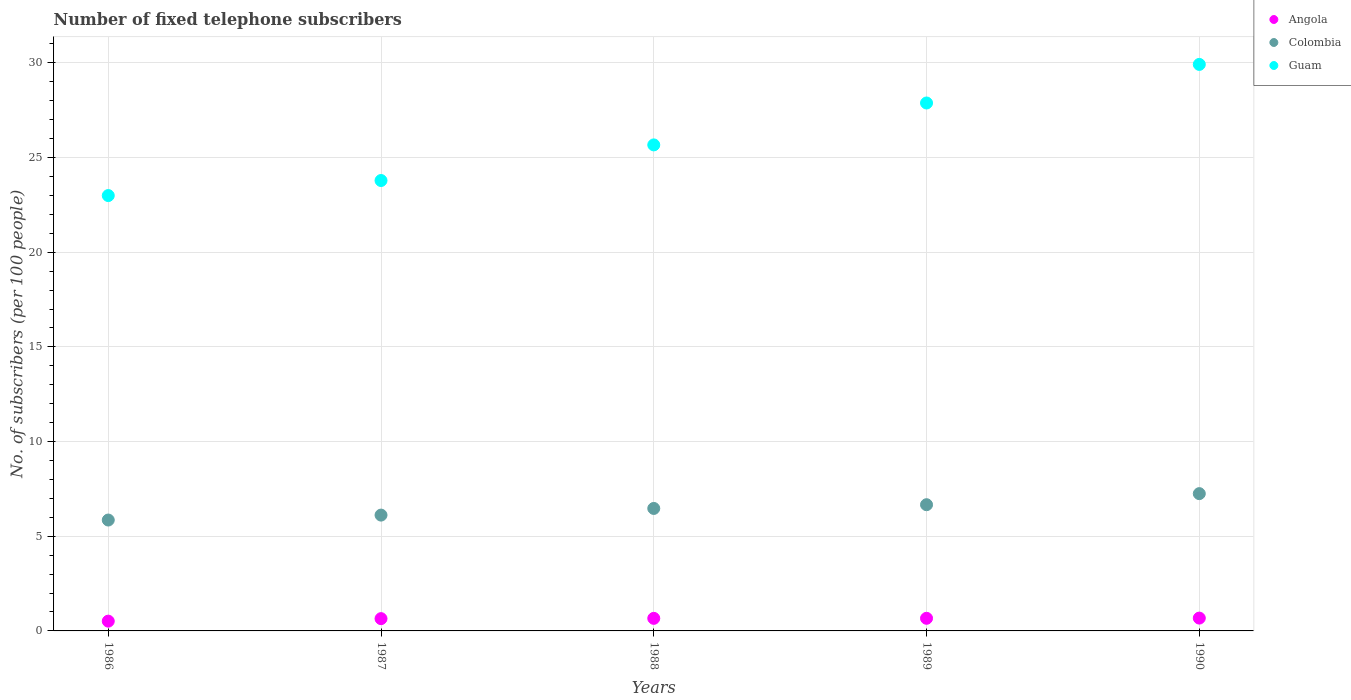How many different coloured dotlines are there?
Offer a very short reply. 3. What is the number of fixed telephone subscribers in Colombia in 1989?
Your response must be concise. 6.66. Across all years, what is the maximum number of fixed telephone subscribers in Colombia?
Keep it short and to the point. 7.25. Across all years, what is the minimum number of fixed telephone subscribers in Colombia?
Make the answer very short. 5.86. What is the total number of fixed telephone subscribers in Colombia in the graph?
Your response must be concise. 32.36. What is the difference between the number of fixed telephone subscribers in Colombia in 1986 and that in 1987?
Your answer should be very brief. -0.26. What is the difference between the number of fixed telephone subscribers in Guam in 1989 and the number of fixed telephone subscribers in Colombia in 1986?
Offer a very short reply. 22.02. What is the average number of fixed telephone subscribers in Guam per year?
Offer a very short reply. 26.05. In the year 1988, what is the difference between the number of fixed telephone subscribers in Guam and number of fixed telephone subscribers in Colombia?
Your response must be concise. 19.2. What is the ratio of the number of fixed telephone subscribers in Angola in 1987 to that in 1989?
Make the answer very short. 0.97. Is the difference between the number of fixed telephone subscribers in Guam in 1986 and 1988 greater than the difference between the number of fixed telephone subscribers in Colombia in 1986 and 1988?
Give a very brief answer. No. What is the difference between the highest and the second highest number of fixed telephone subscribers in Colombia?
Your answer should be compact. 0.59. What is the difference between the highest and the lowest number of fixed telephone subscribers in Angola?
Your answer should be very brief. 0.16. Is the sum of the number of fixed telephone subscribers in Colombia in 1986 and 1989 greater than the maximum number of fixed telephone subscribers in Guam across all years?
Your answer should be very brief. No. Does the number of fixed telephone subscribers in Angola monotonically increase over the years?
Your answer should be compact. Yes. How many dotlines are there?
Provide a short and direct response. 3. Does the graph contain any zero values?
Provide a succinct answer. No. Does the graph contain grids?
Provide a short and direct response. Yes. How many legend labels are there?
Ensure brevity in your answer.  3. What is the title of the graph?
Offer a terse response. Number of fixed telephone subscribers. What is the label or title of the Y-axis?
Provide a succinct answer. No. of subscribers (per 100 people). What is the No. of subscribers (per 100 people) in Angola in 1986?
Offer a terse response. 0.52. What is the No. of subscribers (per 100 people) of Colombia in 1986?
Ensure brevity in your answer.  5.86. What is the No. of subscribers (per 100 people) in Guam in 1986?
Make the answer very short. 22.99. What is the No. of subscribers (per 100 people) of Angola in 1987?
Offer a terse response. 0.65. What is the No. of subscribers (per 100 people) of Colombia in 1987?
Provide a short and direct response. 6.12. What is the No. of subscribers (per 100 people) in Guam in 1987?
Your answer should be compact. 23.79. What is the No. of subscribers (per 100 people) in Angola in 1988?
Give a very brief answer. 0.66. What is the No. of subscribers (per 100 people) in Colombia in 1988?
Ensure brevity in your answer.  6.47. What is the No. of subscribers (per 100 people) of Guam in 1988?
Provide a short and direct response. 25.67. What is the No. of subscribers (per 100 people) of Angola in 1989?
Ensure brevity in your answer.  0.67. What is the No. of subscribers (per 100 people) of Colombia in 1989?
Your answer should be compact. 6.66. What is the No. of subscribers (per 100 people) of Guam in 1989?
Your response must be concise. 27.88. What is the No. of subscribers (per 100 people) in Angola in 1990?
Make the answer very short. 0.68. What is the No. of subscribers (per 100 people) of Colombia in 1990?
Provide a short and direct response. 7.25. What is the No. of subscribers (per 100 people) of Guam in 1990?
Your answer should be very brief. 29.92. Across all years, what is the maximum No. of subscribers (per 100 people) of Angola?
Make the answer very short. 0.68. Across all years, what is the maximum No. of subscribers (per 100 people) of Colombia?
Your response must be concise. 7.25. Across all years, what is the maximum No. of subscribers (per 100 people) of Guam?
Provide a succinct answer. 29.92. Across all years, what is the minimum No. of subscribers (per 100 people) in Angola?
Your response must be concise. 0.52. Across all years, what is the minimum No. of subscribers (per 100 people) of Colombia?
Offer a terse response. 5.86. Across all years, what is the minimum No. of subscribers (per 100 people) in Guam?
Ensure brevity in your answer.  22.99. What is the total No. of subscribers (per 100 people) of Angola in the graph?
Ensure brevity in your answer.  3.17. What is the total No. of subscribers (per 100 people) of Colombia in the graph?
Your response must be concise. 32.36. What is the total No. of subscribers (per 100 people) of Guam in the graph?
Provide a short and direct response. 130.24. What is the difference between the No. of subscribers (per 100 people) in Angola in 1986 and that in 1987?
Ensure brevity in your answer.  -0.13. What is the difference between the No. of subscribers (per 100 people) in Colombia in 1986 and that in 1987?
Keep it short and to the point. -0.26. What is the difference between the No. of subscribers (per 100 people) in Guam in 1986 and that in 1987?
Offer a terse response. -0.79. What is the difference between the No. of subscribers (per 100 people) in Angola in 1986 and that in 1988?
Keep it short and to the point. -0.15. What is the difference between the No. of subscribers (per 100 people) of Colombia in 1986 and that in 1988?
Your answer should be compact. -0.61. What is the difference between the No. of subscribers (per 100 people) of Guam in 1986 and that in 1988?
Ensure brevity in your answer.  -2.68. What is the difference between the No. of subscribers (per 100 people) of Angola in 1986 and that in 1989?
Offer a terse response. -0.15. What is the difference between the No. of subscribers (per 100 people) of Colombia in 1986 and that in 1989?
Your answer should be very brief. -0.81. What is the difference between the No. of subscribers (per 100 people) in Guam in 1986 and that in 1989?
Offer a terse response. -4.89. What is the difference between the No. of subscribers (per 100 people) in Angola in 1986 and that in 1990?
Keep it short and to the point. -0.16. What is the difference between the No. of subscribers (per 100 people) in Colombia in 1986 and that in 1990?
Your answer should be very brief. -1.39. What is the difference between the No. of subscribers (per 100 people) in Guam in 1986 and that in 1990?
Offer a terse response. -6.93. What is the difference between the No. of subscribers (per 100 people) of Angola in 1987 and that in 1988?
Your answer should be very brief. -0.01. What is the difference between the No. of subscribers (per 100 people) of Colombia in 1987 and that in 1988?
Your answer should be very brief. -0.35. What is the difference between the No. of subscribers (per 100 people) in Guam in 1987 and that in 1988?
Offer a terse response. -1.88. What is the difference between the No. of subscribers (per 100 people) of Angola in 1987 and that in 1989?
Keep it short and to the point. -0.02. What is the difference between the No. of subscribers (per 100 people) in Colombia in 1987 and that in 1989?
Give a very brief answer. -0.55. What is the difference between the No. of subscribers (per 100 people) of Guam in 1987 and that in 1989?
Offer a terse response. -4.09. What is the difference between the No. of subscribers (per 100 people) in Angola in 1987 and that in 1990?
Your response must be concise. -0.03. What is the difference between the No. of subscribers (per 100 people) of Colombia in 1987 and that in 1990?
Offer a very short reply. -1.13. What is the difference between the No. of subscribers (per 100 people) in Guam in 1987 and that in 1990?
Provide a short and direct response. -6.13. What is the difference between the No. of subscribers (per 100 people) of Angola in 1988 and that in 1989?
Ensure brevity in your answer.  -0. What is the difference between the No. of subscribers (per 100 people) of Colombia in 1988 and that in 1989?
Provide a succinct answer. -0.2. What is the difference between the No. of subscribers (per 100 people) of Guam in 1988 and that in 1989?
Offer a very short reply. -2.21. What is the difference between the No. of subscribers (per 100 people) of Angola in 1988 and that in 1990?
Ensure brevity in your answer.  -0.01. What is the difference between the No. of subscribers (per 100 people) in Colombia in 1988 and that in 1990?
Offer a terse response. -0.78. What is the difference between the No. of subscribers (per 100 people) in Guam in 1988 and that in 1990?
Provide a short and direct response. -4.25. What is the difference between the No. of subscribers (per 100 people) in Angola in 1989 and that in 1990?
Give a very brief answer. -0.01. What is the difference between the No. of subscribers (per 100 people) in Colombia in 1989 and that in 1990?
Make the answer very short. -0.59. What is the difference between the No. of subscribers (per 100 people) in Guam in 1989 and that in 1990?
Your answer should be very brief. -2.04. What is the difference between the No. of subscribers (per 100 people) of Angola in 1986 and the No. of subscribers (per 100 people) of Colombia in 1987?
Your answer should be very brief. -5.6. What is the difference between the No. of subscribers (per 100 people) in Angola in 1986 and the No. of subscribers (per 100 people) in Guam in 1987?
Your answer should be compact. -23.27. What is the difference between the No. of subscribers (per 100 people) of Colombia in 1986 and the No. of subscribers (per 100 people) of Guam in 1987?
Your answer should be compact. -17.93. What is the difference between the No. of subscribers (per 100 people) in Angola in 1986 and the No. of subscribers (per 100 people) in Colombia in 1988?
Ensure brevity in your answer.  -5.95. What is the difference between the No. of subscribers (per 100 people) of Angola in 1986 and the No. of subscribers (per 100 people) of Guam in 1988?
Provide a succinct answer. -25.15. What is the difference between the No. of subscribers (per 100 people) in Colombia in 1986 and the No. of subscribers (per 100 people) in Guam in 1988?
Keep it short and to the point. -19.81. What is the difference between the No. of subscribers (per 100 people) in Angola in 1986 and the No. of subscribers (per 100 people) in Colombia in 1989?
Give a very brief answer. -6.15. What is the difference between the No. of subscribers (per 100 people) of Angola in 1986 and the No. of subscribers (per 100 people) of Guam in 1989?
Give a very brief answer. -27.36. What is the difference between the No. of subscribers (per 100 people) of Colombia in 1986 and the No. of subscribers (per 100 people) of Guam in 1989?
Provide a succinct answer. -22.02. What is the difference between the No. of subscribers (per 100 people) in Angola in 1986 and the No. of subscribers (per 100 people) in Colombia in 1990?
Keep it short and to the point. -6.73. What is the difference between the No. of subscribers (per 100 people) of Angola in 1986 and the No. of subscribers (per 100 people) of Guam in 1990?
Keep it short and to the point. -29.4. What is the difference between the No. of subscribers (per 100 people) of Colombia in 1986 and the No. of subscribers (per 100 people) of Guam in 1990?
Give a very brief answer. -24.06. What is the difference between the No. of subscribers (per 100 people) of Angola in 1987 and the No. of subscribers (per 100 people) of Colombia in 1988?
Offer a terse response. -5.82. What is the difference between the No. of subscribers (per 100 people) of Angola in 1987 and the No. of subscribers (per 100 people) of Guam in 1988?
Offer a very short reply. -25.02. What is the difference between the No. of subscribers (per 100 people) in Colombia in 1987 and the No. of subscribers (per 100 people) in Guam in 1988?
Your response must be concise. -19.55. What is the difference between the No. of subscribers (per 100 people) in Angola in 1987 and the No. of subscribers (per 100 people) in Colombia in 1989?
Provide a short and direct response. -6.02. What is the difference between the No. of subscribers (per 100 people) of Angola in 1987 and the No. of subscribers (per 100 people) of Guam in 1989?
Provide a short and direct response. -27.23. What is the difference between the No. of subscribers (per 100 people) in Colombia in 1987 and the No. of subscribers (per 100 people) in Guam in 1989?
Provide a succinct answer. -21.76. What is the difference between the No. of subscribers (per 100 people) of Angola in 1987 and the No. of subscribers (per 100 people) of Colombia in 1990?
Ensure brevity in your answer.  -6.6. What is the difference between the No. of subscribers (per 100 people) in Angola in 1987 and the No. of subscribers (per 100 people) in Guam in 1990?
Make the answer very short. -29.27. What is the difference between the No. of subscribers (per 100 people) of Colombia in 1987 and the No. of subscribers (per 100 people) of Guam in 1990?
Make the answer very short. -23.8. What is the difference between the No. of subscribers (per 100 people) of Angola in 1988 and the No. of subscribers (per 100 people) of Colombia in 1989?
Offer a terse response. -6. What is the difference between the No. of subscribers (per 100 people) in Angola in 1988 and the No. of subscribers (per 100 people) in Guam in 1989?
Your response must be concise. -27.22. What is the difference between the No. of subscribers (per 100 people) in Colombia in 1988 and the No. of subscribers (per 100 people) in Guam in 1989?
Your answer should be very brief. -21.41. What is the difference between the No. of subscribers (per 100 people) of Angola in 1988 and the No. of subscribers (per 100 people) of Colombia in 1990?
Give a very brief answer. -6.59. What is the difference between the No. of subscribers (per 100 people) in Angola in 1988 and the No. of subscribers (per 100 people) in Guam in 1990?
Keep it short and to the point. -29.25. What is the difference between the No. of subscribers (per 100 people) of Colombia in 1988 and the No. of subscribers (per 100 people) of Guam in 1990?
Provide a short and direct response. -23.45. What is the difference between the No. of subscribers (per 100 people) of Angola in 1989 and the No. of subscribers (per 100 people) of Colombia in 1990?
Give a very brief answer. -6.58. What is the difference between the No. of subscribers (per 100 people) in Angola in 1989 and the No. of subscribers (per 100 people) in Guam in 1990?
Offer a terse response. -29.25. What is the difference between the No. of subscribers (per 100 people) of Colombia in 1989 and the No. of subscribers (per 100 people) of Guam in 1990?
Your response must be concise. -23.25. What is the average No. of subscribers (per 100 people) in Angola per year?
Provide a short and direct response. 0.63. What is the average No. of subscribers (per 100 people) of Colombia per year?
Your answer should be compact. 6.47. What is the average No. of subscribers (per 100 people) of Guam per year?
Offer a terse response. 26.05. In the year 1986, what is the difference between the No. of subscribers (per 100 people) of Angola and No. of subscribers (per 100 people) of Colombia?
Your answer should be very brief. -5.34. In the year 1986, what is the difference between the No. of subscribers (per 100 people) of Angola and No. of subscribers (per 100 people) of Guam?
Offer a terse response. -22.47. In the year 1986, what is the difference between the No. of subscribers (per 100 people) in Colombia and No. of subscribers (per 100 people) in Guam?
Offer a terse response. -17.13. In the year 1987, what is the difference between the No. of subscribers (per 100 people) of Angola and No. of subscribers (per 100 people) of Colombia?
Offer a terse response. -5.47. In the year 1987, what is the difference between the No. of subscribers (per 100 people) of Angola and No. of subscribers (per 100 people) of Guam?
Ensure brevity in your answer.  -23.14. In the year 1987, what is the difference between the No. of subscribers (per 100 people) of Colombia and No. of subscribers (per 100 people) of Guam?
Offer a terse response. -17.67. In the year 1988, what is the difference between the No. of subscribers (per 100 people) in Angola and No. of subscribers (per 100 people) in Colombia?
Your answer should be compact. -5.8. In the year 1988, what is the difference between the No. of subscribers (per 100 people) of Angola and No. of subscribers (per 100 people) of Guam?
Give a very brief answer. -25. In the year 1988, what is the difference between the No. of subscribers (per 100 people) in Colombia and No. of subscribers (per 100 people) in Guam?
Offer a very short reply. -19.2. In the year 1989, what is the difference between the No. of subscribers (per 100 people) in Angola and No. of subscribers (per 100 people) in Colombia?
Provide a short and direct response. -6. In the year 1989, what is the difference between the No. of subscribers (per 100 people) of Angola and No. of subscribers (per 100 people) of Guam?
Ensure brevity in your answer.  -27.21. In the year 1989, what is the difference between the No. of subscribers (per 100 people) of Colombia and No. of subscribers (per 100 people) of Guam?
Your answer should be very brief. -21.21. In the year 1990, what is the difference between the No. of subscribers (per 100 people) of Angola and No. of subscribers (per 100 people) of Colombia?
Give a very brief answer. -6.57. In the year 1990, what is the difference between the No. of subscribers (per 100 people) in Angola and No. of subscribers (per 100 people) in Guam?
Your answer should be compact. -29.24. In the year 1990, what is the difference between the No. of subscribers (per 100 people) of Colombia and No. of subscribers (per 100 people) of Guam?
Offer a terse response. -22.67. What is the ratio of the No. of subscribers (per 100 people) in Angola in 1986 to that in 1987?
Make the answer very short. 0.8. What is the ratio of the No. of subscribers (per 100 people) in Colombia in 1986 to that in 1987?
Your answer should be very brief. 0.96. What is the ratio of the No. of subscribers (per 100 people) of Guam in 1986 to that in 1987?
Keep it short and to the point. 0.97. What is the ratio of the No. of subscribers (per 100 people) of Angola in 1986 to that in 1988?
Provide a short and direct response. 0.78. What is the ratio of the No. of subscribers (per 100 people) of Colombia in 1986 to that in 1988?
Provide a short and direct response. 0.91. What is the ratio of the No. of subscribers (per 100 people) of Guam in 1986 to that in 1988?
Provide a succinct answer. 0.9. What is the ratio of the No. of subscribers (per 100 people) of Angola in 1986 to that in 1989?
Give a very brief answer. 0.77. What is the ratio of the No. of subscribers (per 100 people) of Colombia in 1986 to that in 1989?
Provide a succinct answer. 0.88. What is the ratio of the No. of subscribers (per 100 people) in Guam in 1986 to that in 1989?
Make the answer very short. 0.82. What is the ratio of the No. of subscribers (per 100 people) in Angola in 1986 to that in 1990?
Provide a short and direct response. 0.76. What is the ratio of the No. of subscribers (per 100 people) in Colombia in 1986 to that in 1990?
Make the answer very short. 0.81. What is the ratio of the No. of subscribers (per 100 people) in Guam in 1986 to that in 1990?
Your answer should be very brief. 0.77. What is the ratio of the No. of subscribers (per 100 people) in Angola in 1987 to that in 1988?
Give a very brief answer. 0.98. What is the ratio of the No. of subscribers (per 100 people) of Colombia in 1987 to that in 1988?
Your response must be concise. 0.95. What is the ratio of the No. of subscribers (per 100 people) of Guam in 1987 to that in 1988?
Ensure brevity in your answer.  0.93. What is the ratio of the No. of subscribers (per 100 people) of Angola in 1987 to that in 1989?
Keep it short and to the point. 0.97. What is the ratio of the No. of subscribers (per 100 people) of Colombia in 1987 to that in 1989?
Your answer should be compact. 0.92. What is the ratio of the No. of subscribers (per 100 people) in Guam in 1987 to that in 1989?
Your answer should be compact. 0.85. What is the ratio of the No. of subscribers (per 100 people) of Angola in 1987 to that in 1990?
Give a very brief answer. 0.96. What is the ratio of the No. of subscribers (per 100 people) in Colombia in 1987 to that in 1990?
Make the answer very short. 0.84. What is the ratio of the No. of subscribers (per 100 people) of Guam in 1987 to that in 1990?
Give a very brief answer. 0.8. What is the ratio of the No. of subscribers (per 100 people) of Angola in 1988 to that in 1989?
Ensure brevity in your answer.  1. What is the ratio of the No. of subscribers (per 100 people) of Colombia in 1988 to that in 1989?
Ensure brevity in your answer.  0.97. What is the ratio of the No. of subscribers (per 100 people) in Guam in 1988 to that in 1989?
Keep it short and to the point. 0.92. What is the ratio of the No. of subscribers (per 100 people) in Angola in 1988 to that in 1990?
Your answer should be very brief. 0.98. What is the ratio of the No. of subscribers (per 100 people) in Colombia in 1988 to that in 1990?
Offer a very short reply. 0.89. What is the ratio of the No. of subscribers (per 100 people) of Guam in 1988 to that in 1990?
Your answer should be compact. 0.86. What is the ratio of the No. of subscribers (per 100 people) in Angola in 1989 to that in 1990?
Provide a short and direct response. 0.98. What is the ratio of the No. of subscribers (per 100 people) of Colombia in 1989 to that in 1990?
Ensure brevity in your answer.  0.92. What is the ratio of the No. of subscribers (per 100 people) of Guam in 1989 to that in 1990?
Your response must be concise. 0.93. What is the difference between the highest and the second highest No. of subscribers (per 100 people) in Angola?
Ensure brevity in your answer.  0.01. What is the difference between the highest and the second highest No. of subscribers (per 100 people) in Colombia?
Provide a short and direct response. 0.59. What is the difference between the highest and the second highest No. of subscribers (per 100 people) of Guam?
Provide a succinct answer. 2.04. What is the difference between the highest and the lowest No. of subscribers (per 100 people) in Angola?
Your answer should be compact. 0.16. What is the difference between the highest and the lowest No. of subscribers (per 100 people) of Colombia?
Your answer should be very brief. 1.39. What is the difference between the highest and the lowest No. of subscribers (per 100 people) in Guam?
Your answer should be compact. 6.93. 